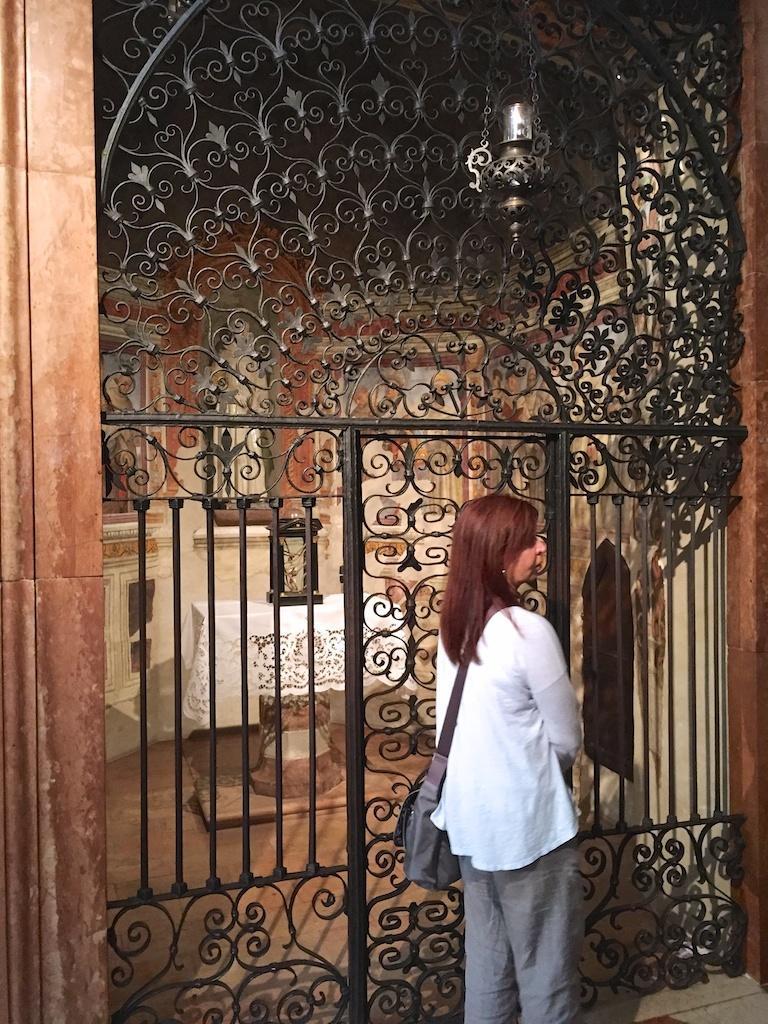In one or two sentences, can you explain what this image depicts? In the foreground of this image, there is a woman standing, wearing a bag. In the background, there is a grill gate. Behind it, there is an object on a table and the wall. 